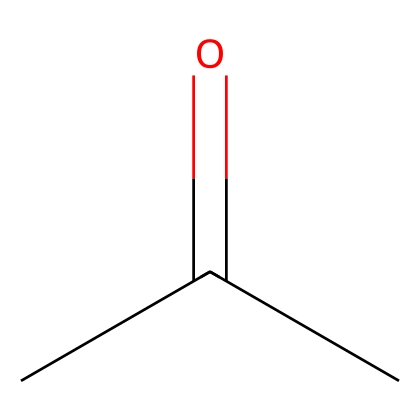What is the chemical name for this structure? The chemical structure CC(=O)C corresponds to acetone, which is a well-known solvent. The presence of a carbonyl group (C=O) and the overall arrangement of carbon and hydrogen atoms identify it as acetone.
Answer: acetone How many carbon atoms are present in this molecule? The SMILES representation shows three carbon atoms (C) in the chain, indicated by the three 'C' notations in the structure.
Answer: three What type of functional group does acetone contain? Acetone features a carbonyl group (C=O), which is the defining functional group for ketones. This is evident from the "=O" part in the SMILES, indicating a double bond between carbon and oxygen.
Answer: carbonyl Is acetone polar or nonpolar? The presence of the polar carbonyl group (C=O) makes acetone a polar solvent overall despite its relatively small size and overall structure.
Answer: polar What is the boiling point range of acetone? Acetone has a boiling point of around 56 degrees Celsius, which can be deduced from common knowledge about the solvent's characteristics.
Answer: 56 degrees Celsius What is the primary use of acetone in relation to vinyl decals? Acetone is primarily used as a solvent in adhesive removers for vinyl decals due to its ability to dissolve various types of adhesives effectively.
Answer: adhesive remover How many hydrogen atoms are present in this molecule? In the structure of acetone, for every carbon atom, there are multiple hydrogen atoms, yielding a total of six hydrogen atoms when counting them based on tetravalency of carbon. This is determined from the SMILES by calculating the number of hydrogen atoms attached to each carbon.
Answer: six 